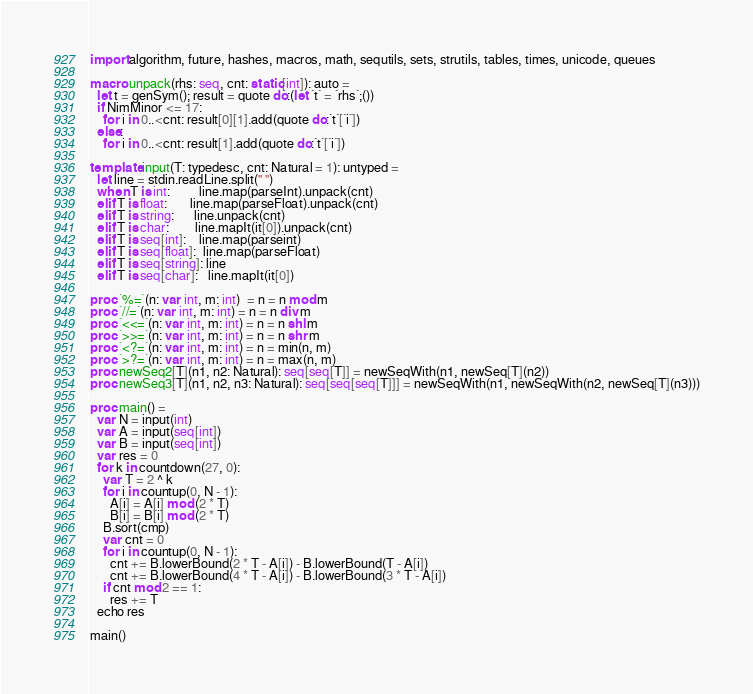Convert code to text. <code><loc_0><loc_0><loc_500><loc_500><_Nim_>import algorithm, future, hashes, macros, math, sequtils, sets, strutils, tables, times, unicode, queues

macro unpack(rhs: seq, cnt: static[int]): auto =
  let t = genSym(); result = quote do:(let `t` = `rhs`;())
  if NimMinor <= 17:
    for i in 0..<cnt: result[0][1].add(quote do:`t`[`i`])
  else:
    for i in 0..<cnt: result[1].add(quote do:`t`[`i`])

template input(T: typedesc, cnt: Natural = 1): untyped =
  let line = stdin.readLine.split(" ")
  when T is int:         line.map(parseInt).unpack(cnt)
  elif T is float:       line.map(parseFloat).unpack(cnt)
  elif T is string:      line.unpack(cnt)
  elif T is char:        line.mapIt(it[0]).unpack(cnt)
  elif T is seq[int]:    line.map(parseint)
  elif T is seq[float]:  line.map(parseFloat)
  elif T is seq[string]: line
  elif T is seq[char]:   line.mapIt(it[0])

proc `%=`(n: var int, m: int)  = n = n mod m
proc `//=`(n: var int, m: int) = n = n div m
proc `<<=`(n: var int, m: int) = n = n shl m
proc `>>=`(n: var int, m: int) = n = n shr m
proc `<?=`(n: var int, m: int) = n = min(n, m)
proc `>?=`(n: var int, m: int) = n = max(n, m)
proc newSeq2[T](n1, n2: Natural): seq[seq[T]] = newSeqWith(n1, newSeq[T](n2))
proc newSeq3[T](n1, n2, n3: Natural): seq[seq[seq[T]]] = newSeqWith(n1, newSeqWith(n2, newSeq[T](n3)))

proc main() =
  var N = input(int)
  var A = input(seq[int])
  var B = input(seq[int])
  var res = 0
  for k in countdown(27, 0):
    var T = 2 ^ k
    for i in countup(0, N - 1):
      A[i] = A[i] mod (2 * T)
      B[i] = B[i] mod (2 * T)
    B.sort(cmp)
    var cnt = 0
    for i in countup(0, N - 1):
      cnt += B.lowerBound(2 * T - A[i]) - B.lowerBound(T - A[i])
      cnt += B.lowerBound(4 * T - A[i]) - B.lowerBound(3 * T - A[i])
    if cnt mod 2 == 1:
      res += T
  echo res

main()</code> 